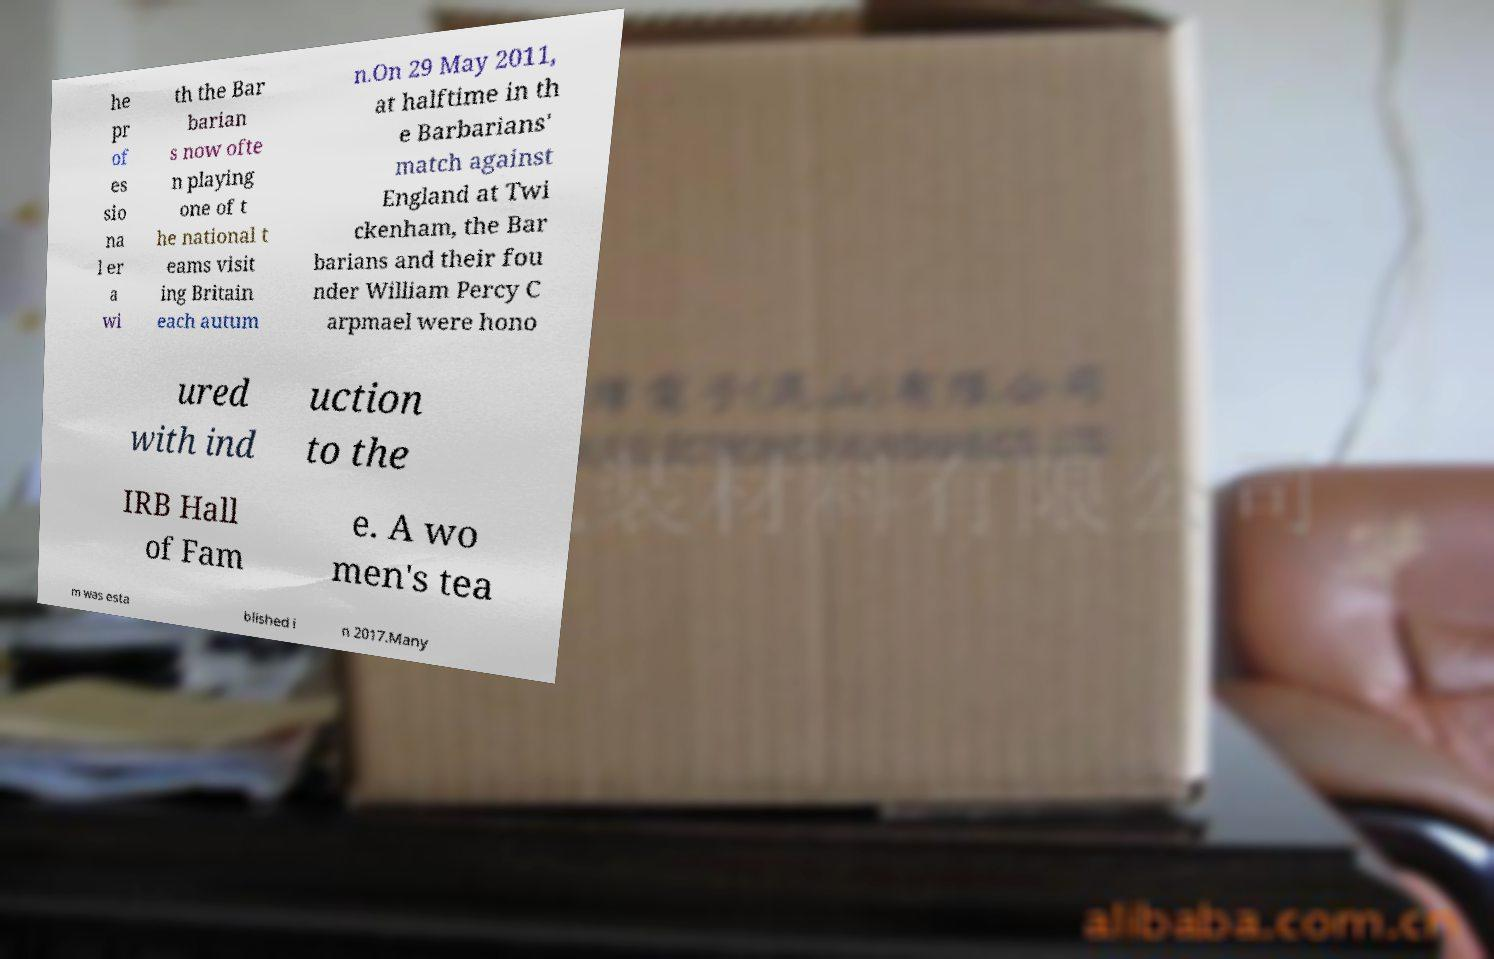For documentation purposes, I need the text within this image transcribed. Could you provide that? he pr of es sio na l er a wi th the Bar barian s now ofte n playing one of t he national t eams visit ing Britain each autum n.On 29 May 2011, at halftime in th e Barbarians' match against England at Twi ckenham, the Bar barians and their fou nder William Percy C arpmael were hono ured with ind uction to the IRB Hall of Fam e. A wo men's tea m was esta blished i n 2017.Many 